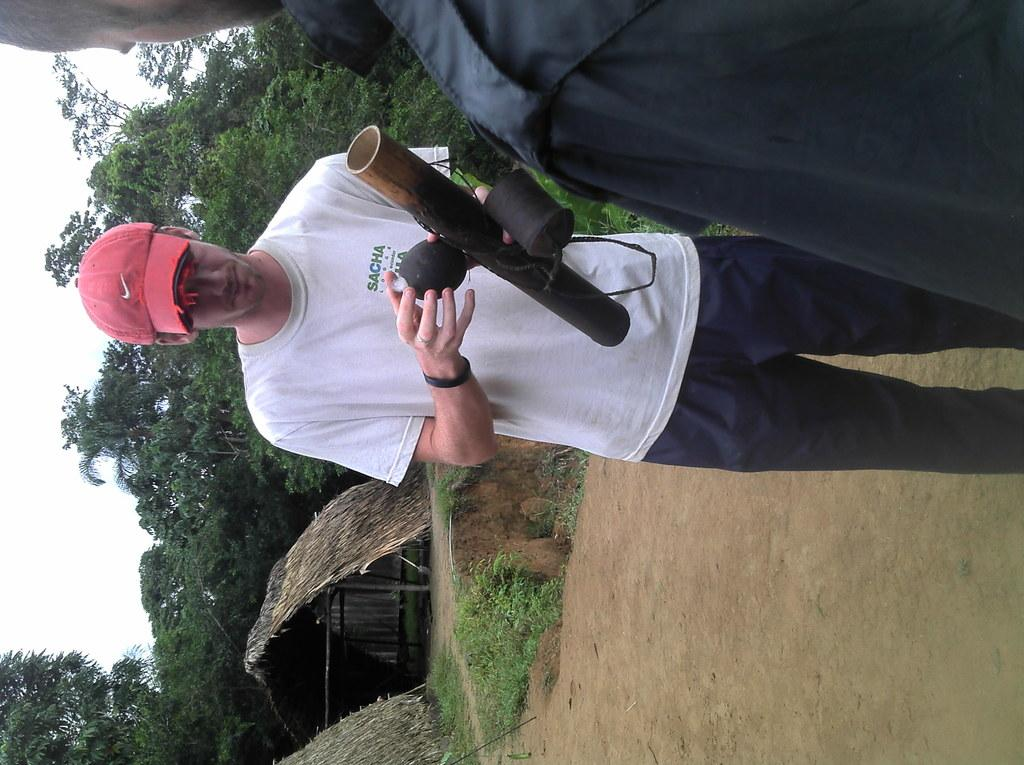How many people are in the image? There are two persons in the image. What is one of the persons doing in the image? One of the persons is holding an object. What can be seen in the background of the image? There are huts, grass, trees, and the sky visible in the background of the image. What type of brush is being used by the person in the image? There is no brush present in the image. How does the person slip on the grass in the image? The person does not slip on the grass in the image; they are standing or holding an object. 